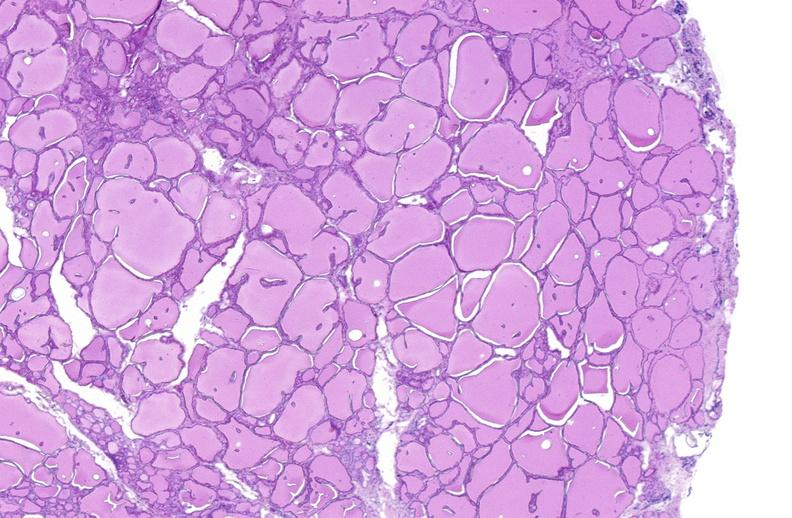what is present?
Answer the question using a single word or phrase. Endocrine 